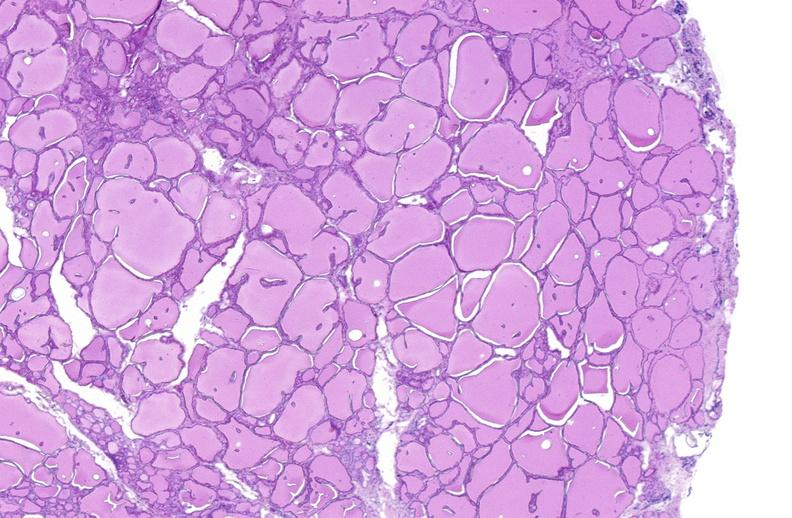what is present?
Answer the question using a single word or phrase. Endocrine 